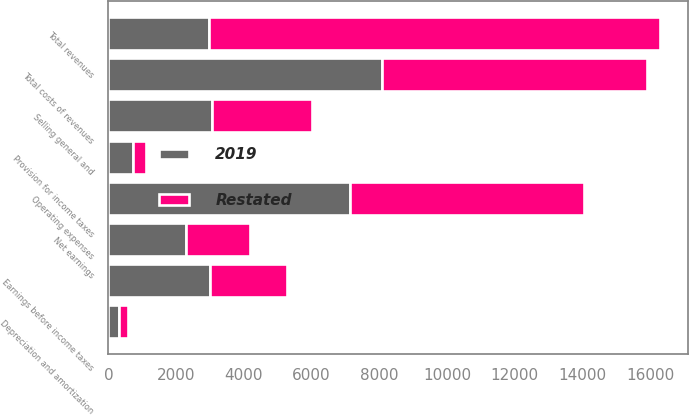Convert chart. <chart><loc_0><loc_0><loc_500><loc_500><stacked_bar_chart><ecel><fcel>Total revenues<fcel>Operating expenses<fcel>Depreciation and amortization<fcel>Total costs of revenues<fcel>Selling general and<fcel>Earnings before income taxes<fcel>Provision for income taxes<fcel>Net earnings<nl><fcel>2019<fcel>2959.4<fcel>7145.9<fcel>304.4<fcel>8086.6<fcel>3064.2<fcel>3005.6<fcel>712.8<fcel>2292.8<nl><fcel>Restated<fcel>13327.7<fcel>6901<fcel>274.5<fcel>7810.9<fcel>2959.4<fcel>2282.6<fcel>397.7<fcel>1884.9<nl></chart> 